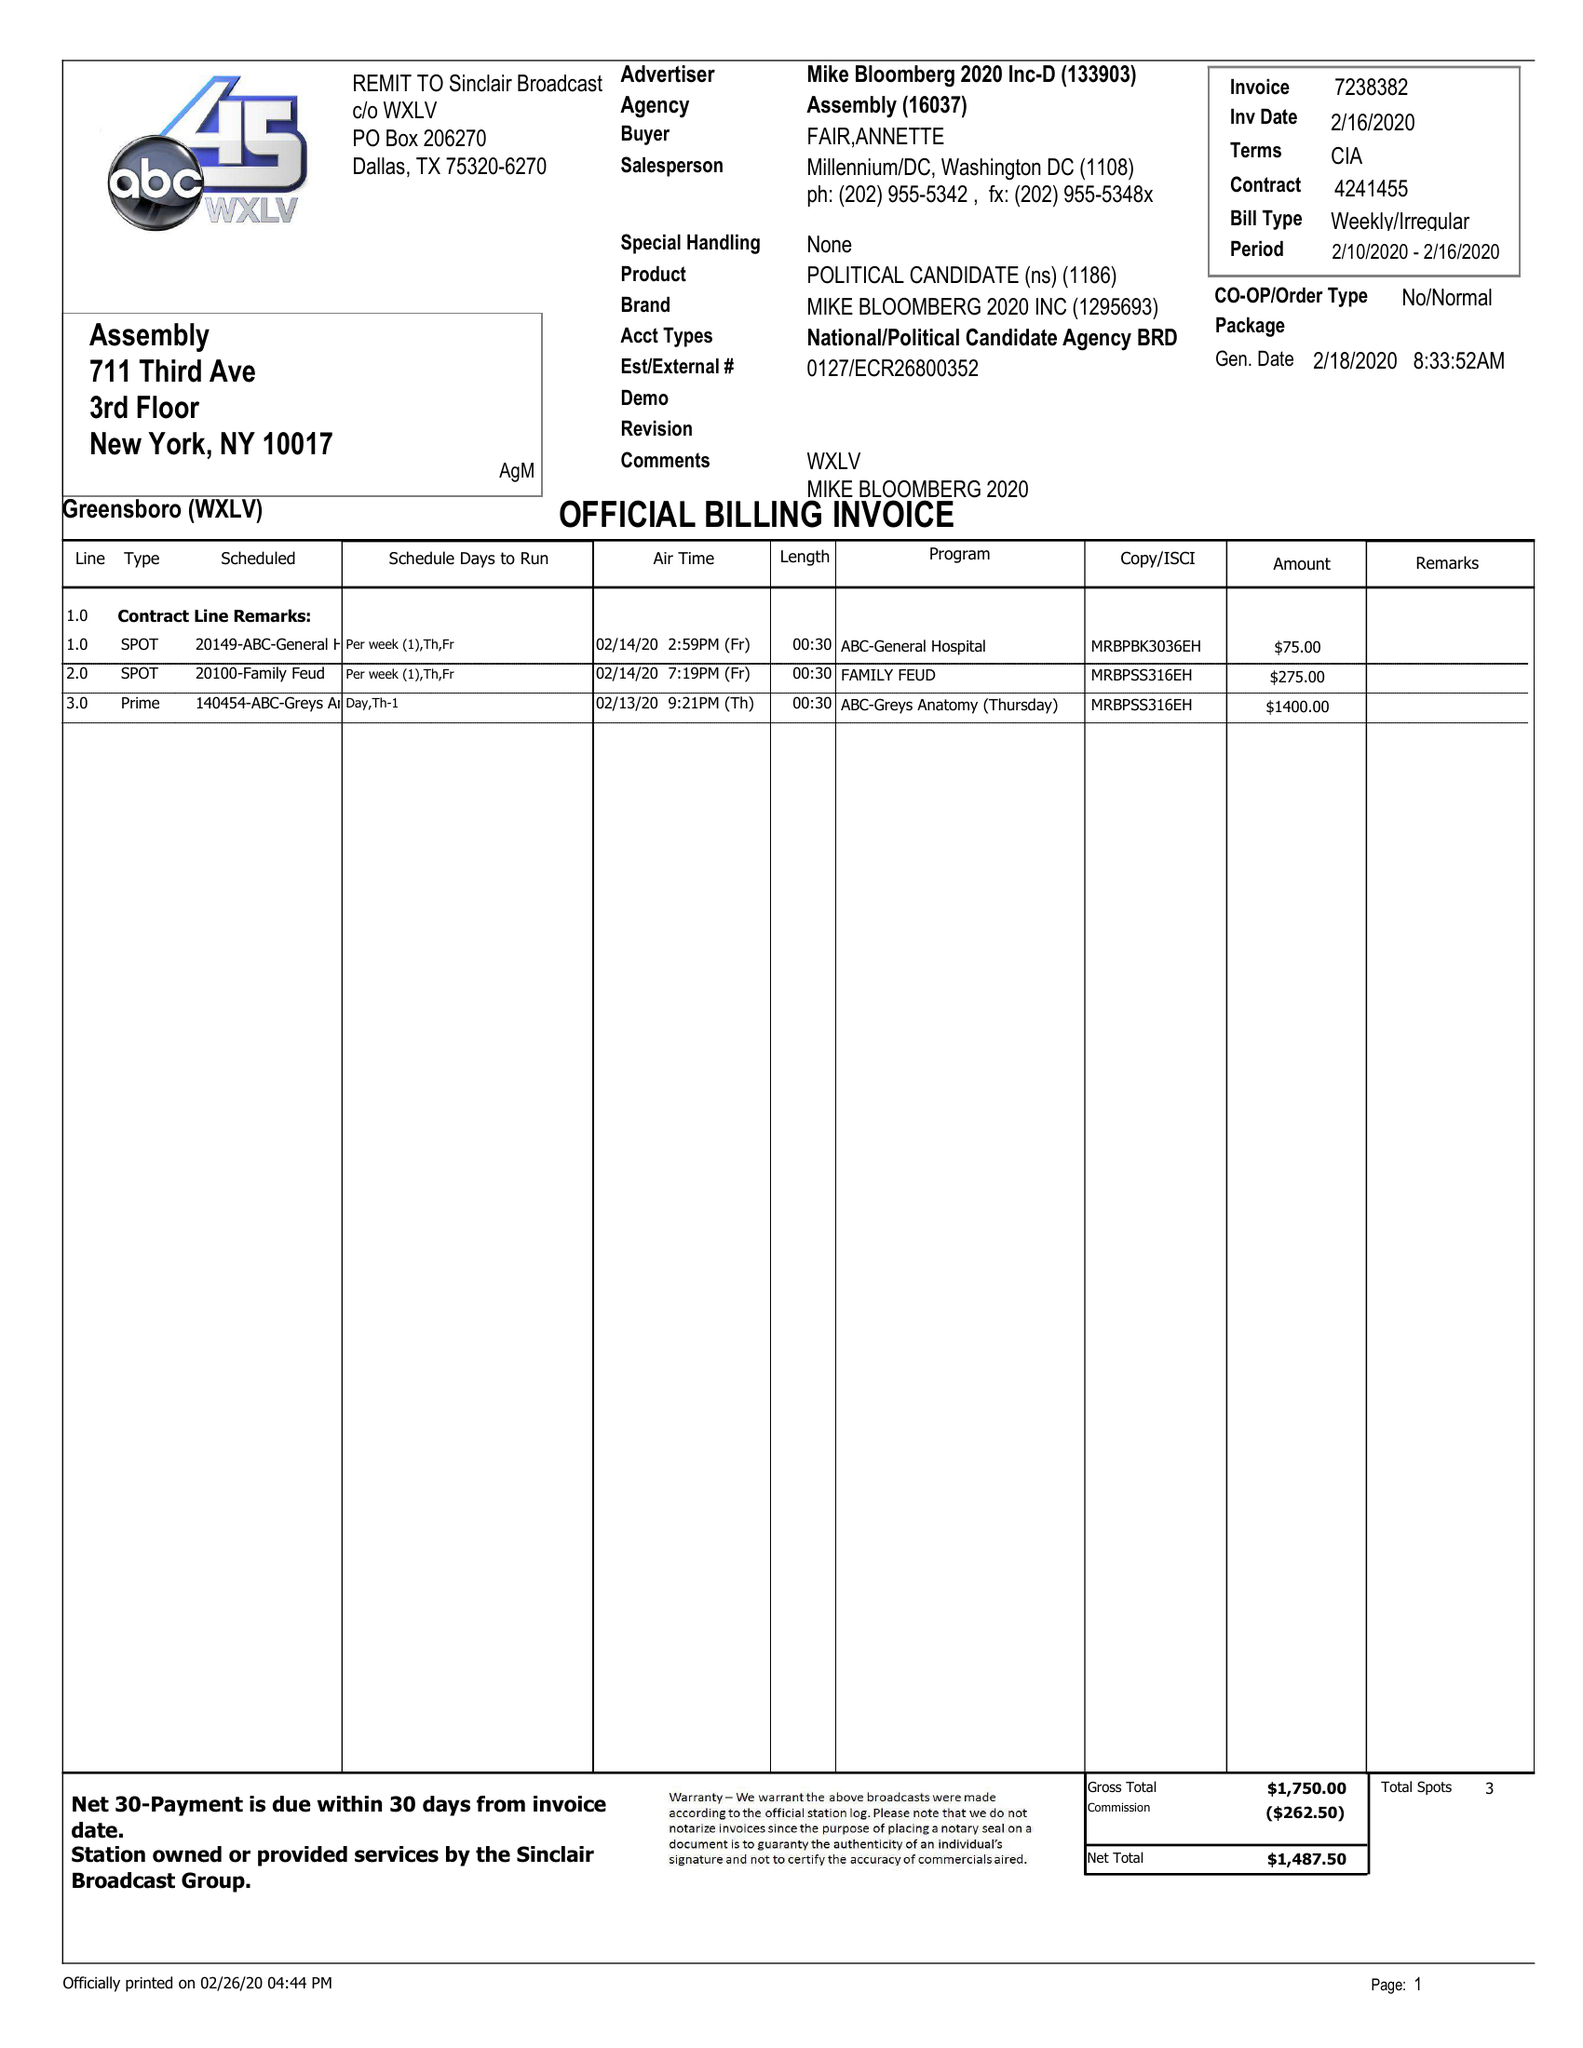What is the value for the flight_from?
Answer the question using a single word or phrase. 02/10/20 